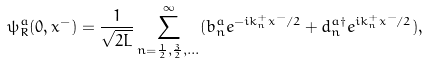Convert formula to latex. <formula><loc_0><loc_0><loc_500><loc_500>\psi _ { R } ^ { a } ( 0 , x ^ { - } ) = \frac { 1 } { \sqrt { 2 L } } \sum _ { n = \frac { 1 } { 2 } , \frac { 3 } { 2 } , \dots } ^ { \infty } ( b _ { n } ^ { a } e ^ { - i k _ { n } ^ { + } x ^ { - } / 2 } + d _ { n } ^ { a \dag } e ^ { i k _ { n } ^ { + } x ^ { - } / 2 } ) ,</formula> 